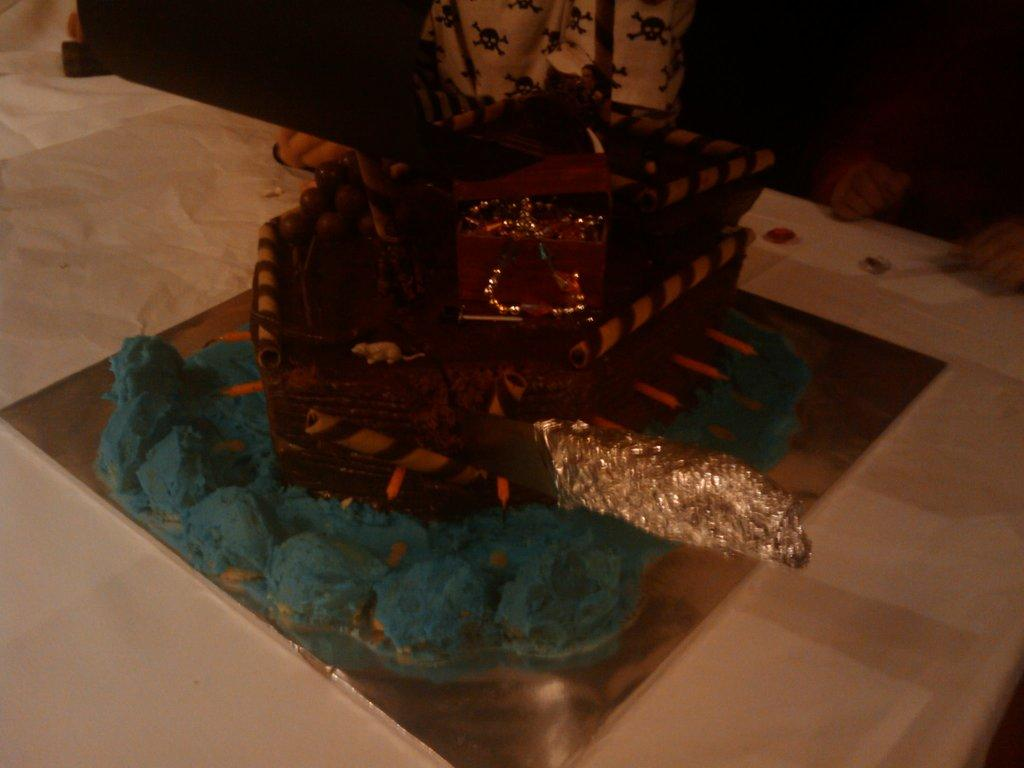What is the main object on the white surface in the image? There is an object on a white surface in the image, but the specific object is not mentioned in the facts. Can you describe the people at the top of the image? The facts only mention that there are two people at the top of the image, but their appearance or actions are not described. What type of cart is being used by the insect in the image? There is no cart or insect present in the image. How many sponges are visible in the image? The facts do not mention any sponges in the image. 